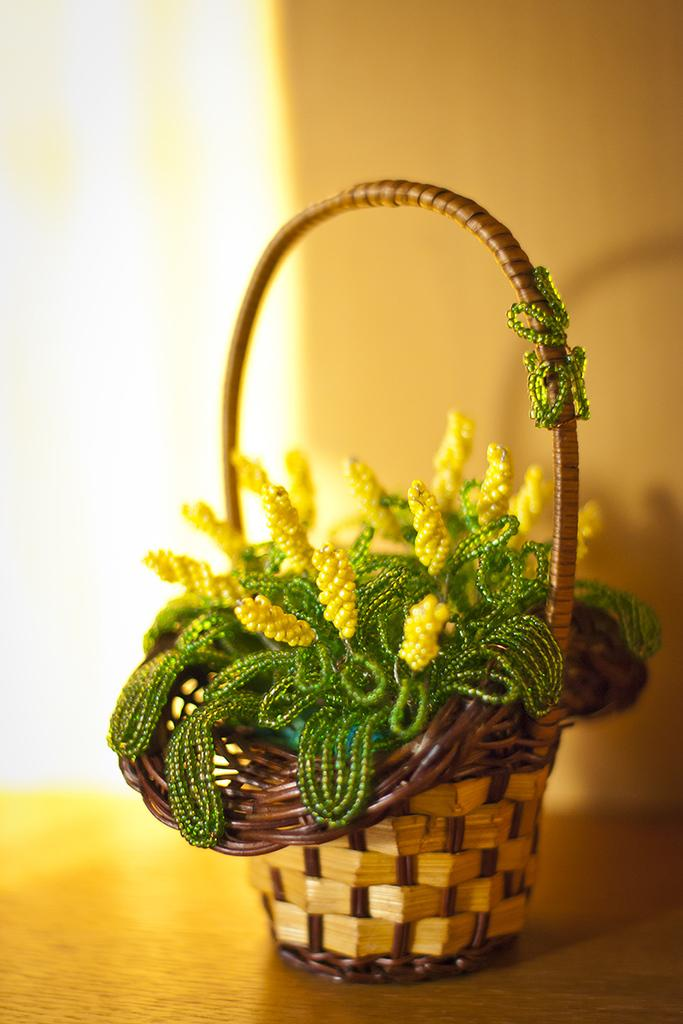What is the main object in the image? There is a small basket in the image. What is the basket placed on? The basket is on a wooden object. What is inside the basket? There are decorative items in the basket. What can be seen behind the basket? There is a wall behind the basket. How many dogs are visible in the image? There are no dogs present in the image. Can you describe the men in the image? There are no men present in the image. 